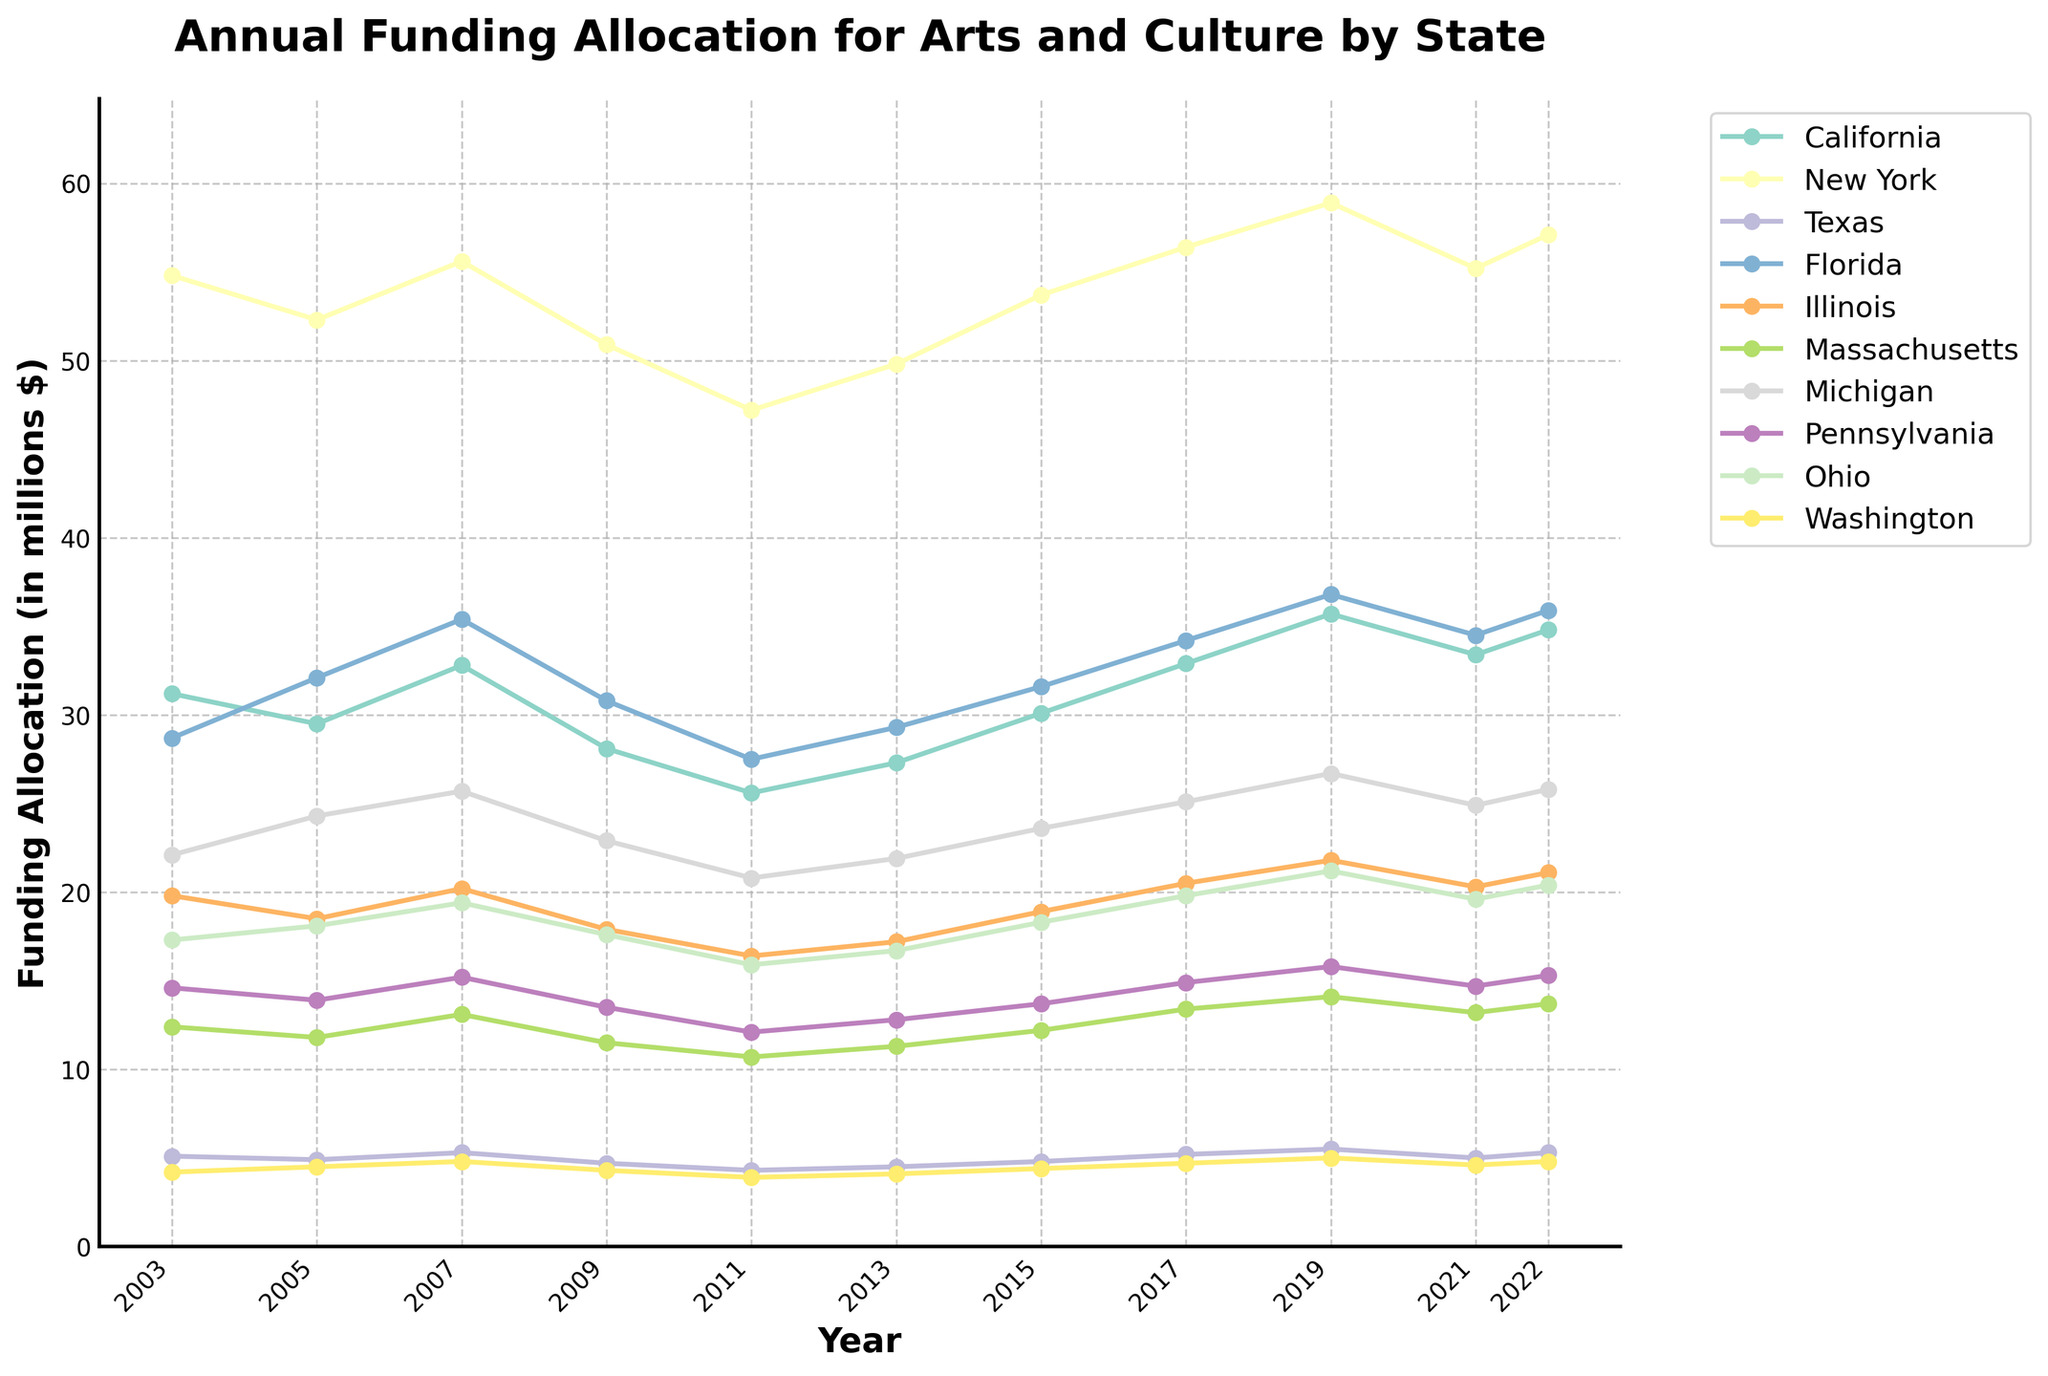Which state had the highest funding allocation for arts and culture in 2022? By visually inspecting the plot, look for the highest line on the graph in the year 2022. The highest peak corresponds to New York.
Answer: New York How did the funding for arts and culture in Texas change from 2003 to 2021? Identify the points for Texas in the years 2003 and 2021. In 2003, Texas had 5.1 million and in 2021, it had 5.0 million. Calculate the difference: 5.0 - 5.1 = -0.1.
Answer: Decreased by 0.1 million Which states showed an overall increase in funding from 2003 to 2022? Compare funding for each state in 2003 and 2022. If the value in 2022 is higher than that in 2003, it indicates an increase. California, New York, Florida, Illinois, Massachusetts, and Washington have higher values in 2022.
Answer: California, New York, Florida, Illinois, Massachusetts, Washington What is the average funding allocation of Illinois over the 20-year period? Sum the funding values for Illinois for each listed year and divide by the number of years. Values: 19.8, 18.5, 20.2, 17.9, 16.4, 17.2, 18.9, 20.5, 21.8, 20.3, 21.1. Total = 212.6; Number of years = 11. 212.6 / 11 = 19.33.
Answer: 19.33 million Which state had the most volatile funding allocation for arts and culture? Observe the lines on the chart and look for the one with the most ups and downs, indicating high variance. New York's line shows the steepest changes.
Answer: New York By how much did the funding in California change from 2007 to 2017? Identify the values for California in 2007 and 2017. In 2007, it was 32.8 million, and in 2017, it was 32.9 million. Calculate the difference: 32.9 - 32.8 = 0.1.
Answer: Increased by 0.1 million Comparing Florida and Michigan, which state had higher funding in the majority of the years? Visually compare the lines for Florida and Michigan to see which one is higher in most years. Florida's line is consistently higher than Michigan's in most of the years displayed.
Answer: Florida In what year did Massachusetts see its lowest funding? By inspecting the chart, find the lowest point for Massachusetts. The lowest funding for Massachusetts was in 2011 with 10.7 million.
Answer: 2011 What was the total funding allocation for the arts and culture by New York over the entire period? Add the funding allocations for New York from each year presented: 54.8, 52.3, 55.6, 50.9, 47.2, 49.8, 53.7, 56.4, 58.9, 55.2, 57.1. Total = 592.9.
Answer: 592.9 million 